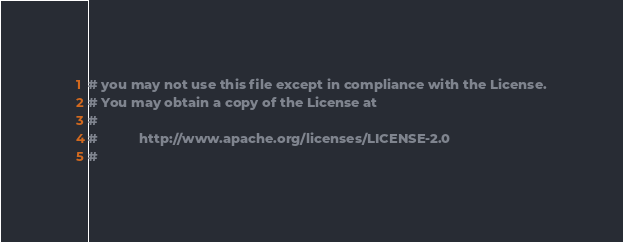Convert code to text. <code><loc_0><loc_0><loc_500><loc_500><_Python_># you may not use this file except in compliance with the License.
# You may obtain a copy of the License at
#
#           http://www.apache.org/licenses/LICENSE-2.0
#</code> 